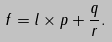Convert formula to latex. <formula><loc_0><loc_0><loc_500><loc_500>f = l \times p + \frac { q } { r } .</formula> 